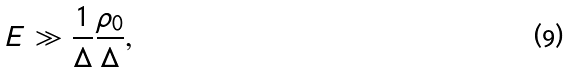Convert formula to latex. <formula><loc_0><loc_0><loc_500><loc_500>E \gg \frac { 1 } { \Delta } \frac { \rho _ { 0 } } { \Delta } ,</formula> 